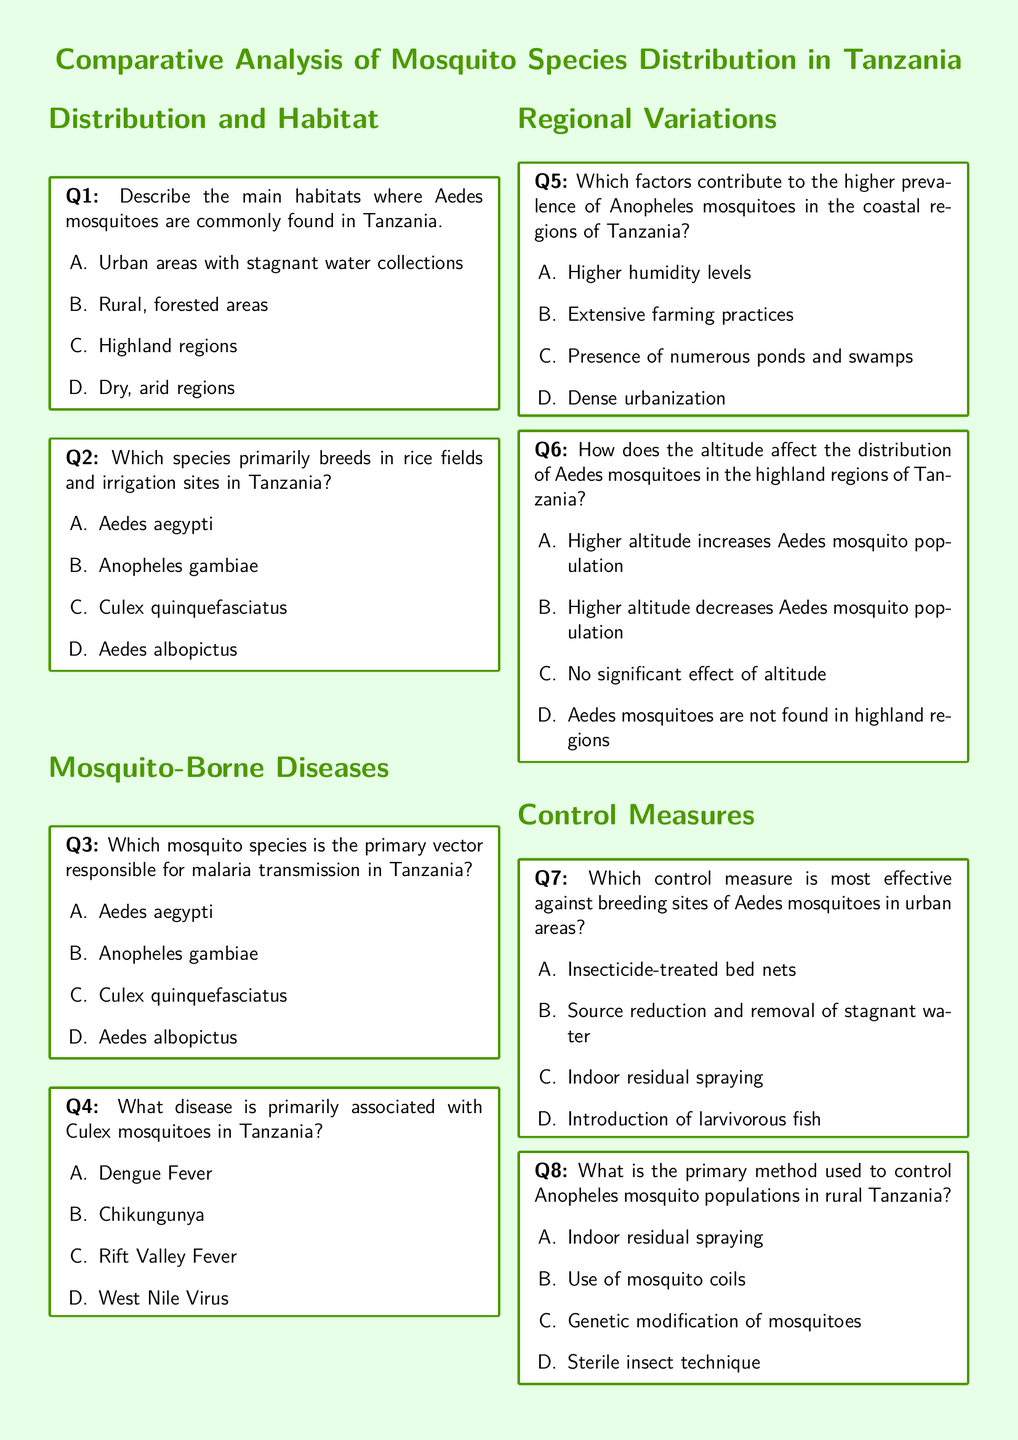What are the main habitats for Aedes mosquitoes? The document lists the main habitats where Aedes mosquitoes are commonly found in Tanzania as urban areas with stagnant water collections.
Answer: Urban areas with stagnant water collections Which mosquito species breeds in rice fields? The document specifies that Culex quinquefasciatus primarily breeds in rice fields and irrigation sites in Tanzania.
Answer: Culex quinquefasciatus What is the primary vector for malaria? According to the document, Anopheles gambiae is the primary mosquito species responsible for malaria transmission in Tanzania.
Answer: Anopheles gambiae What disease is associated with Culex mosquitoes? The document states that West Nile Virus is primarily associated with Culex mosquitoes in Tanzania.
Answer: West Nile Virus What factors increase Anopheles prevalence in coastal regions? The document indicates that higher humidity levels contribute to the higher prevalence of Anopheles mosquitoes in coastal regions.
Answer: Higher humidity levels How does altitude affect Aedes populations? The document notes that higher altitude decreases Aedes mosquito population in the highland regions of Tanzania.
Answer: Higher altitude decreases Aedes mosquito population What is the most effective control measure against Aedes mosquitoes? The document mentions that source reduction and removal of stagnant water is the most effective control measure against breeding sites of Aedes mosquitoes in urban areas.
Answer: Source reduction and removal of stagnant water What is the primary method for controlling Anopheles populations? Indoor residual spraying is identified in the document as the primary method used to control Anopheles mosquito populations in rural Tanzania.
Answer: Indoor residual spraying 